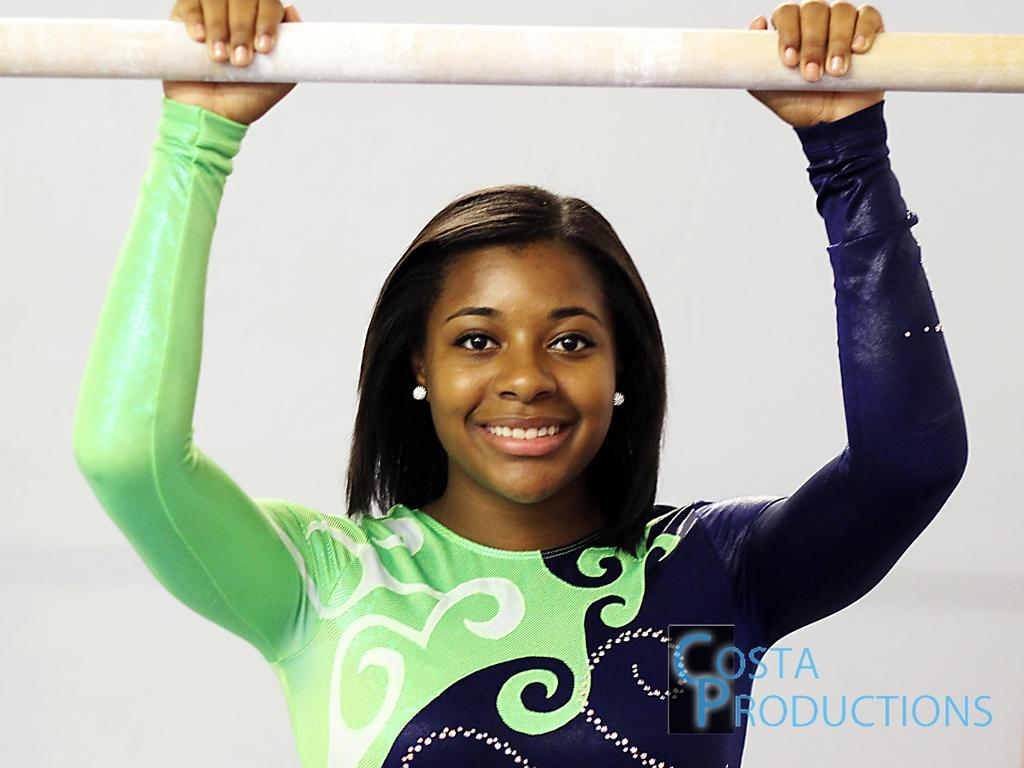Who is the main subject in the image? There is a woman in the image. What is the woman holding in her hand? The woman is holding a stick in her hand. What color is the background of the image? The background of the image is white. Where is the text located in the image? The text is in the right bottom of the image. How many times does the woman sneeze in the image? The woman does not sneeze in the image. 